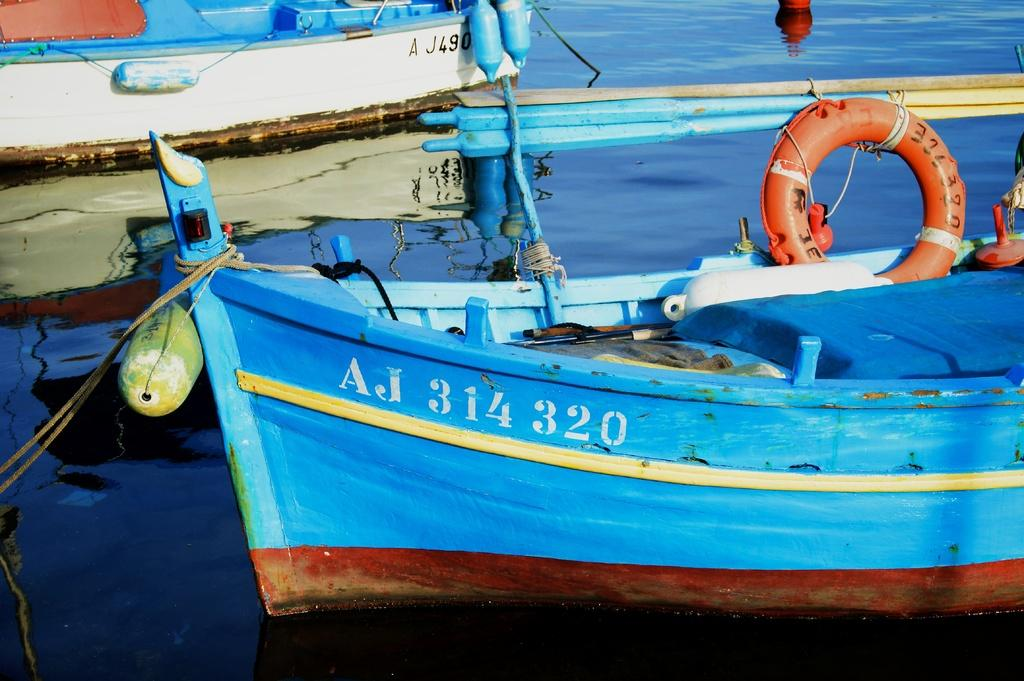<image>
Give a short and clear explanation of the subsequent image. The blue boat numbered AJ 314 320 sits with a rope tied to it. 